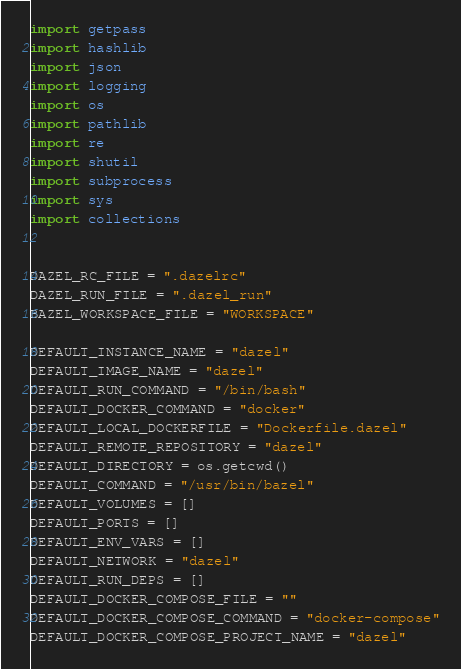<code> <loc_0><loc_0><loc_500><loc_500><_Python_>import getpass
import hashlib
import json
import logging
import os
import pathlib
import re
import shutil
import subprocess
import sys
import collections


DAZEL_RC_FILE = ".dazelrc"
DAZEL_RUN_FILE = ".dazel_run"
BAZEL_WORKSPACE_FILE = "WORKSPACE"

DEFAULT_INSTANCE_NAME = "dazel"
DEFAULT_IMAGE_NAME = "dazel"
DEFAULT_RUN_COMMAND = "/bin/bash"
DEFAULT_DOCKER_COMMAND = "docker"
DEFAULT_LOCAL_DOCKERFILE = "Dockerfile.dazel"
DEFAULT_REMOTE_REPOSITORY = "dazel"
DEFAULT_DIRECTORY = os.getcwd()
DEFAULT_COMMAND = "/usr/bin/bazel"
DEFAULT_VOLUMES = []
DEFAULT_PORTS = []
DEFAULT_ENV_VARS = []
DEFAULT_NETWORK = "dazel"
DEFAULT_RUN_DEPS = []
DEFAULT_DOCKER_COMPOSE_FILE = ""
DEFAULT_DOCKER_COMPOSE_COMMAND = "docker-compose"
DEFAULT_DOCKER_COMPOSE_PROJECT_NAME = "dazel"</code> 